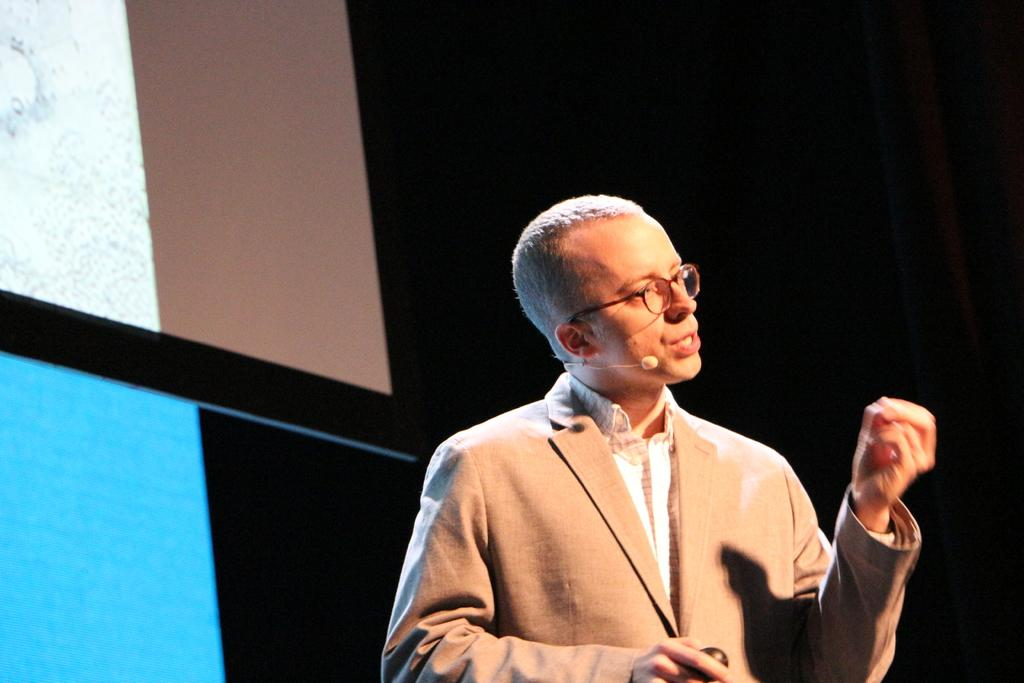Who is the main subject in the image? There is a man in the image. What is the man wearing in the image? The man is wearing spectacles and a blazer in the image. What is the man doing in the image? The man is talking on a microphone in the image. What is the color of the background in the image? The background of the image is dark. Can you see any feathers on the man's blazer in the image? There are no feathers visible on the man's blazer in the image. What type of operation is the man performing in the image? The image does not depict any operation; the man is talking on a microphone. 